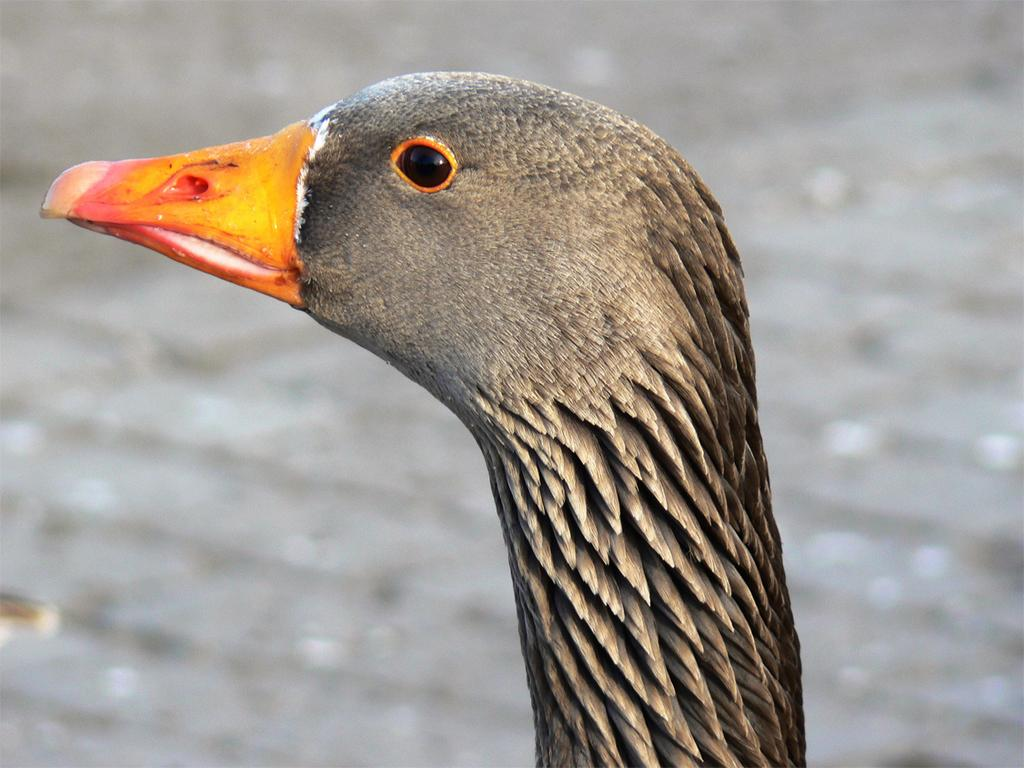What type of animal is featured in the image? The image contains the head of a goose. Can you describe the background of the image? The background of the image is blurred. What type of coast can be seen in the image? There is no coast present in the image; it features the head of a goose with a blurred background. 